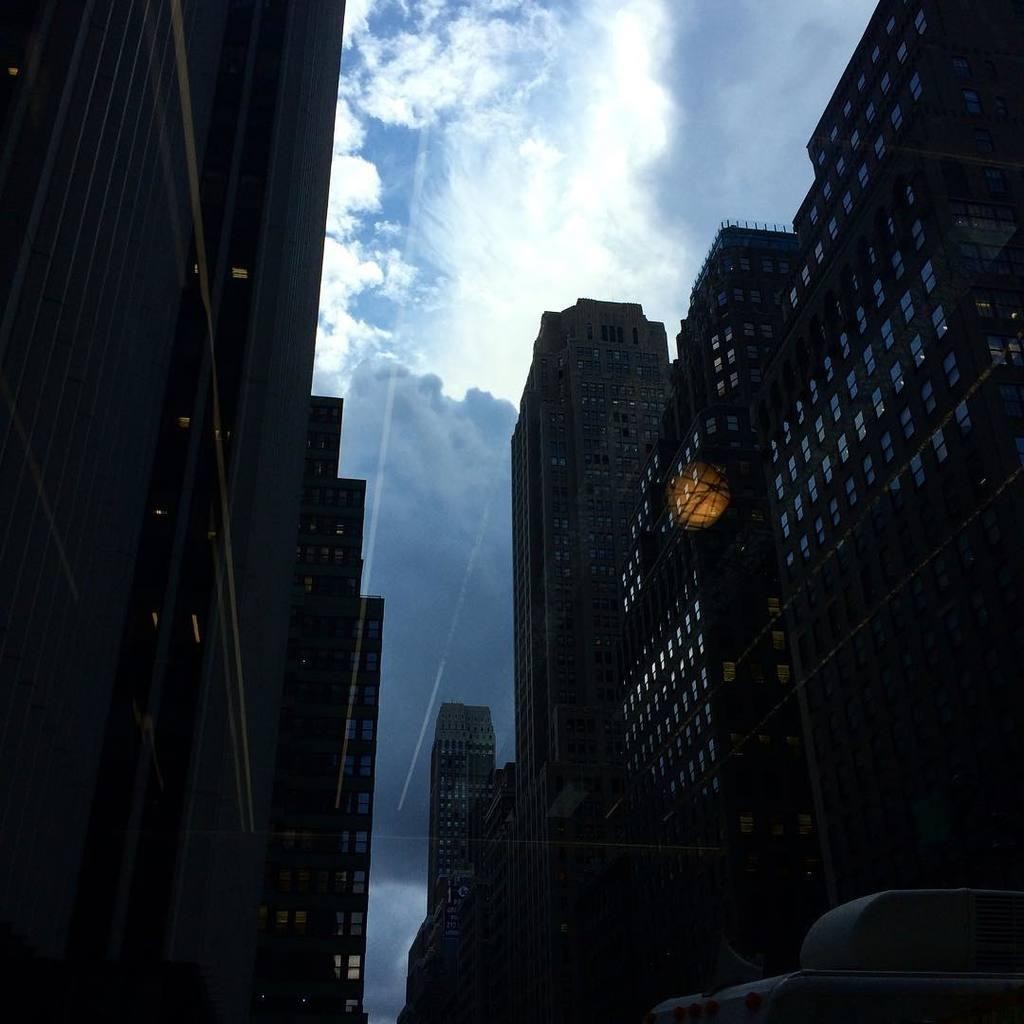What type of structures can be seen in the image? There are buildings in the image. What else is visible in the foreground of the image? There are vehicles in the foreground of the image. How would you describe the sky in the image? The sky is cloudy in the image. What color is the dress worn by the baseball player in the image? There is no baseball player or dress present in the image. 